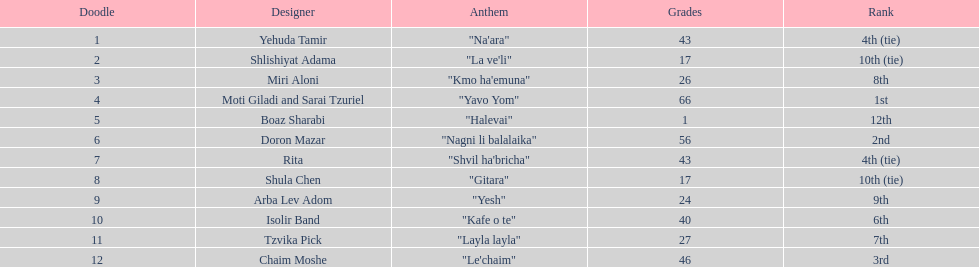What song is listed in the table right before layla layla? "Kafe o te". 